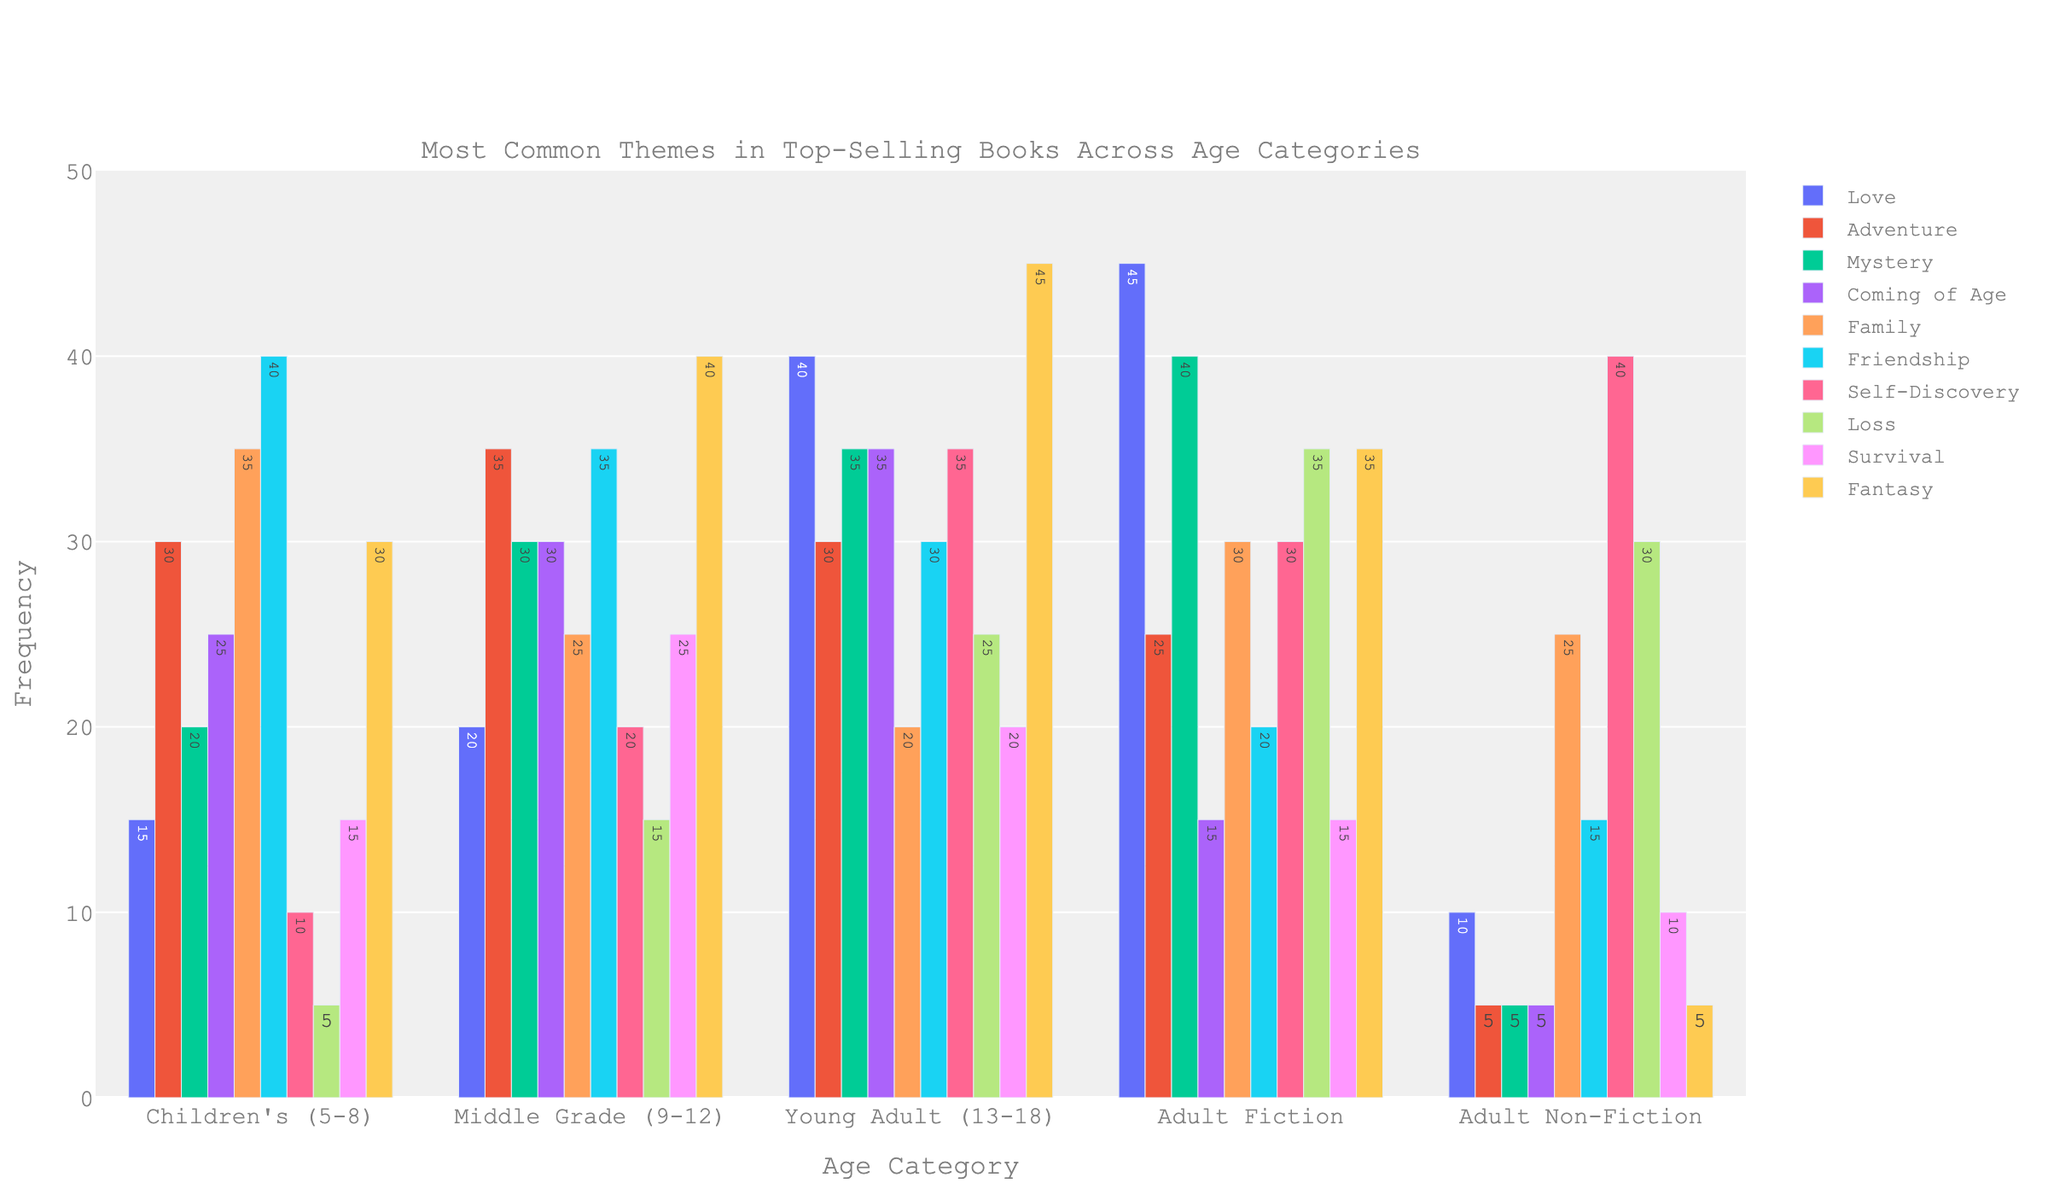What is the most common theme in Children's books? The highest bar in the Children's (5-8) category corresponds to Friendship, indicating it is the most common theme.
Answer: Friendship Which age category has the highest frequency of the Fantasy theme? The highest bar for the Fantasy theme is in the Young Adult (13-18) category.
Answer: Young Adult (13-18) How does the frequency of Self-Discovery in Adult Non-Fiction compare to Fiction? Self-Discovery has a frequency of 40 in Adult Non-Fiction and 30 in Adult Fiction, so it is higher in Non-Fiction.
Answer: Higher in Non-Fiction What is the sum of frequencies for the Love theme across all age categories? Adding the Love frequencies: 15 (Children's) + 20 (Middle Grade) + 40 (Young Adult) + 45 (Adult Fiction) + 10 (Adult Non-Fiction) = 130
Answer: 130 Which theme has the least frequency in Middle Grade books? The shortest bar in Middle Grade (9-12) corresponds to Family.
Answer: Family Is the frequency of Adventure higher in Middle Grade books or Adult Fiction? Adventure has a frequency of 35 in Middle Grade and 25 in Adult Fiction, so it is higher in Middle Grade.
Answer: Middle Grade What is the average frequency of themes in Adult Non-Fiction books? Summing up all theme frequencies in Adult Non-Fiction: 10 + 5 + 5 + 5 + 25 + 15 + 40 + 30 + 10 + 5 = 150. There are 10 themes, so the average is 150/10 = 15
Answer: 15 Which age category has the most balanced distribution of theme frequencies? By visually inspecting the plots, Middle Grade (9-12) appears to have relatively even bar heights compared to the other categories.
Answer: Middle Grade (9-12) In which age category is the theme of Mystery most common? The Mystery theme has the highest frequency in Adult Fiction (40).
Answer: Adult Fiction What's the difference in the frequency of Coming of Age between Young Adult and Children's books? Subtracting the Coming of Age frequency of Children's from Young Adult: 35 (Young Adult) - 25 (Children's) = 10
Answer: 10 